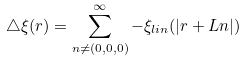<formula> <loc_0><loc_0><loc_500><loc_500>\bigtriangleup \xi ( { r } ) = \sum _ { { n } \neq ( 0 , 0 , 0 ) } ^ { \infty } - \xi _ { l i n } ( | { r } + L { n } | )</formula> 